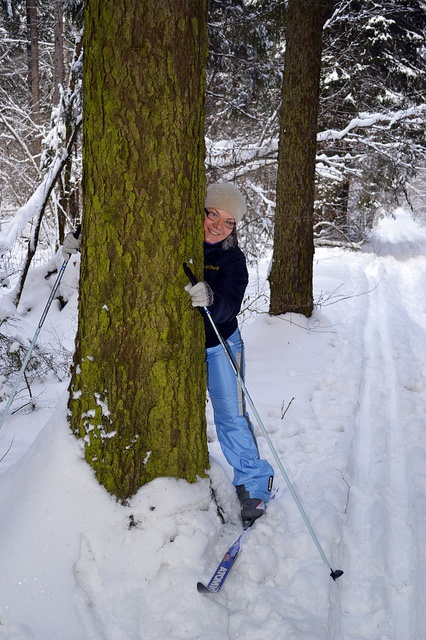Describe the objects in this image and their specific colors. I can see people in black, gray, and darkgray tones and skis in black, darkgray, gray, and navy tones in this image. 